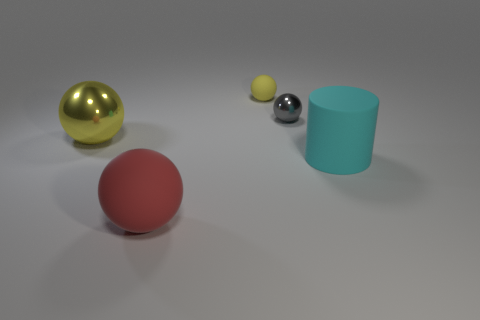What material is the thing that is right of the tiny yellow matte ball and behind the cyan cylinder?
Your answer should be compact. Metal. There is another metallic sphere that is the same size as the red sphere; what is its color?
Your response must be concise. Yellow. Does the small yellow thing have the same material as the ball in front of the big metal thing?
Offer a terse response. Yes. How many other objects are there of the same size as the red thing?
Ensure brevity in your answer.  2. There is a yellow thing behind the big sphere on the left side of the large red ball; are there any large cyan things left of it?
Offer a terse response. No. What size is the red ball?
Provide a short and direct response. Large. There is a yellow ball that is in front of the tiny matte thing; what is its size?
Make the answer very short. Large. There is a yellow sphere that is in front of the yellow rubber object; is its size the same as the gray ball?
Ensure brevity in your answer.  No. Is there anything else that is the same color as the cylinder?
Your answer should be compact. No. There is a large cyan matte thing; what shape is it?
Provide a short and direct response. Cylinder. 